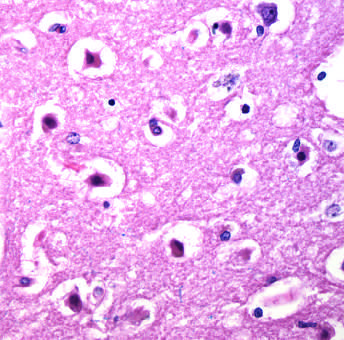re the nuclei pyknotic?
Answer the question using a single word or phrase. Yes 